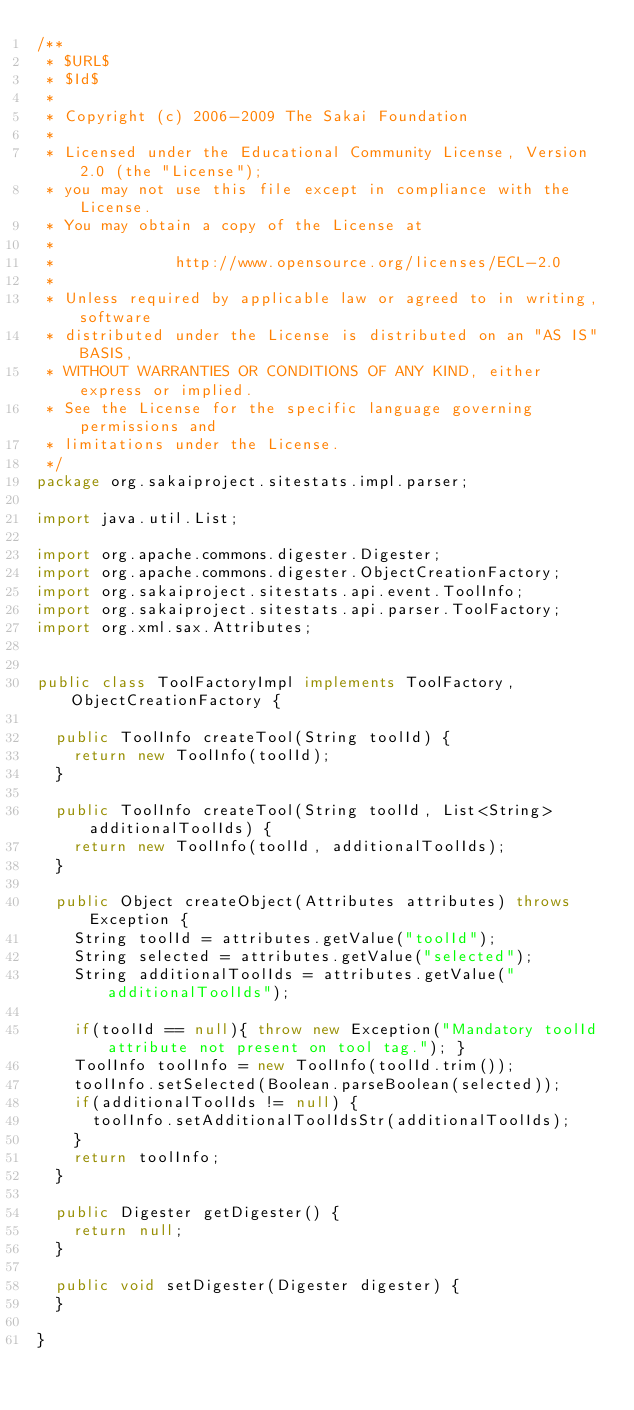<code> <loc_0><loc_0><loc_500><loc_500><_Java_>/**
 * $URL$
 * $Id$
 *
 * Copyright (c) 2006-2009 The Sakai Foundation
 *
 * Licensed under the Educational Community License, Version 2.0 (the "License");
 * you may not use this file except in compliance with the License.
 * You may obtain a copy of the License at
 *
 *             http://www.opensource.org/licenses/ECL-2.0
 *
 * Unless required by applicable law or agreed to in writing, software
 * distributed under the License is distributed on an "AS IS" BASIS,
 * WITHOUT WARRANTIES OR CONDITIONS OF ANY KIND, either express or implied.
 * See the License for the specific language governing permissions and
 * limitations under the License.
 */
package org.sakaiproject.sitestats.impl.parser;

import java.util.List;

import org.apache.commons.digester.Digester;
import org.apache.commons.digester.ObjectCreationFactory;
import org.sakaiproject.sitestats.api.event.ToolInfo;
import org.sakaiproject.sitestats.api.parser.ToolFactory;
import org.xml.sax.Attributes;


public class ToolFactoryImpl implements ToolFactory, ObjectCreationFactory {

	public ToolInfo createTool(String toolId) {
		return new ToolInfo(toolId);
	}
	
	public ToolInfo createTool(String toolId, List<String> additionalToolIds) {
		return new ToolInfo(toolId, additionalToolIds);
	}
	
	public Object createObject(Attributes attributes) throws Exception {
		String toolId = attributes.getValue("toolId");
		String selected = attributes.getValue("selected");
		String additionalToolIds = attributes.getValue("additionalToolIds");

		if(toolId == null){ throw new Exception("Mandatory toolId attribute not present on tool tag."); }
		ToolInfo toolInfo = new ToolInfo(toolId.trim());
		toolInfo.setSelected(Boolean.parseBoolean(selected));
		if(additionalToolIds != null) {
			toolInfo.setAdditionalToolIdsStr(additionalToolIds);
		}
		return toolInfo;
	}

	public Digester getDigester() {
		return null;
	}

	public void setDigester(Digester digester) {
	}

}
</code> 